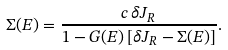<formula> <loc_0><loc_0><loc_500><loc_500>\Sigma ( E ) = \frac { c \, \delta J _ { R } } { 1 - G ( E ) \, [ \delta J _ { R } - \Sigma ( E ) ] } .</formula> 